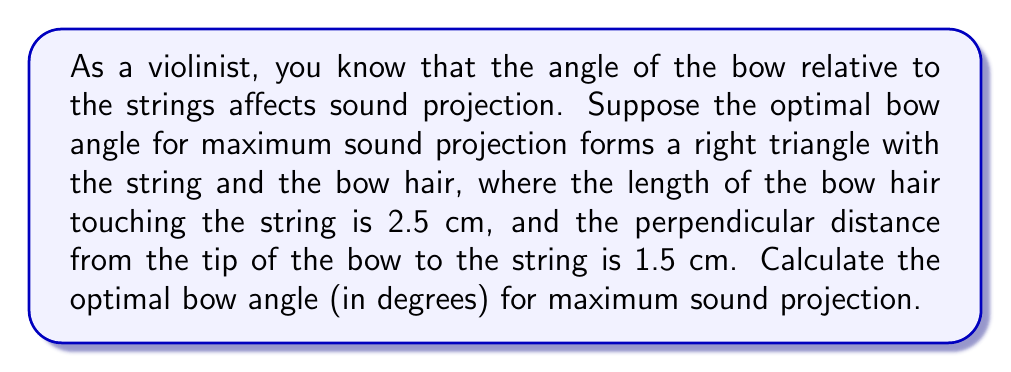Show me your answer to this math problem. Let's approach this step-by-step using trigonometric ratios:

1) We can visualize the problem as a right triangle where:
   - The hypotenuse is the bow
   - The opposite side is the perpendicular distance from the tip of the bow to the string (1.5 cm)
   - The adjacent side is the length of the bow hair touching the string (2.5 cm)

2) We need to find the angle between the hypotenuse (bow) and the adjacent side (string). This angle can be calculated using the inverse tangent function (arctan or $\tan^{-1}$).

3) In a right triangle, $\tan(\theta) = \frac{\text{opposite}}{\text{adjacent}}$

4) Substituting our values:

   $\tan(\theta) = \frac{1.5}{2.5}$

5) To find $\theta$, we take the inverse tangent of both sides:

   $\theta = \tan^{-1}(\frac{1.5}{2.5})$

6) Using a calculator or computer:

   $\theta \approx 30.96^\circ$

7) Round to two decimal places:

   $\theta \approx 30.96^\circ$

Therefore, the optimal bow angle for maximum sound projection is approximately 30.96°.
Answer: $30.96^\circ$ 